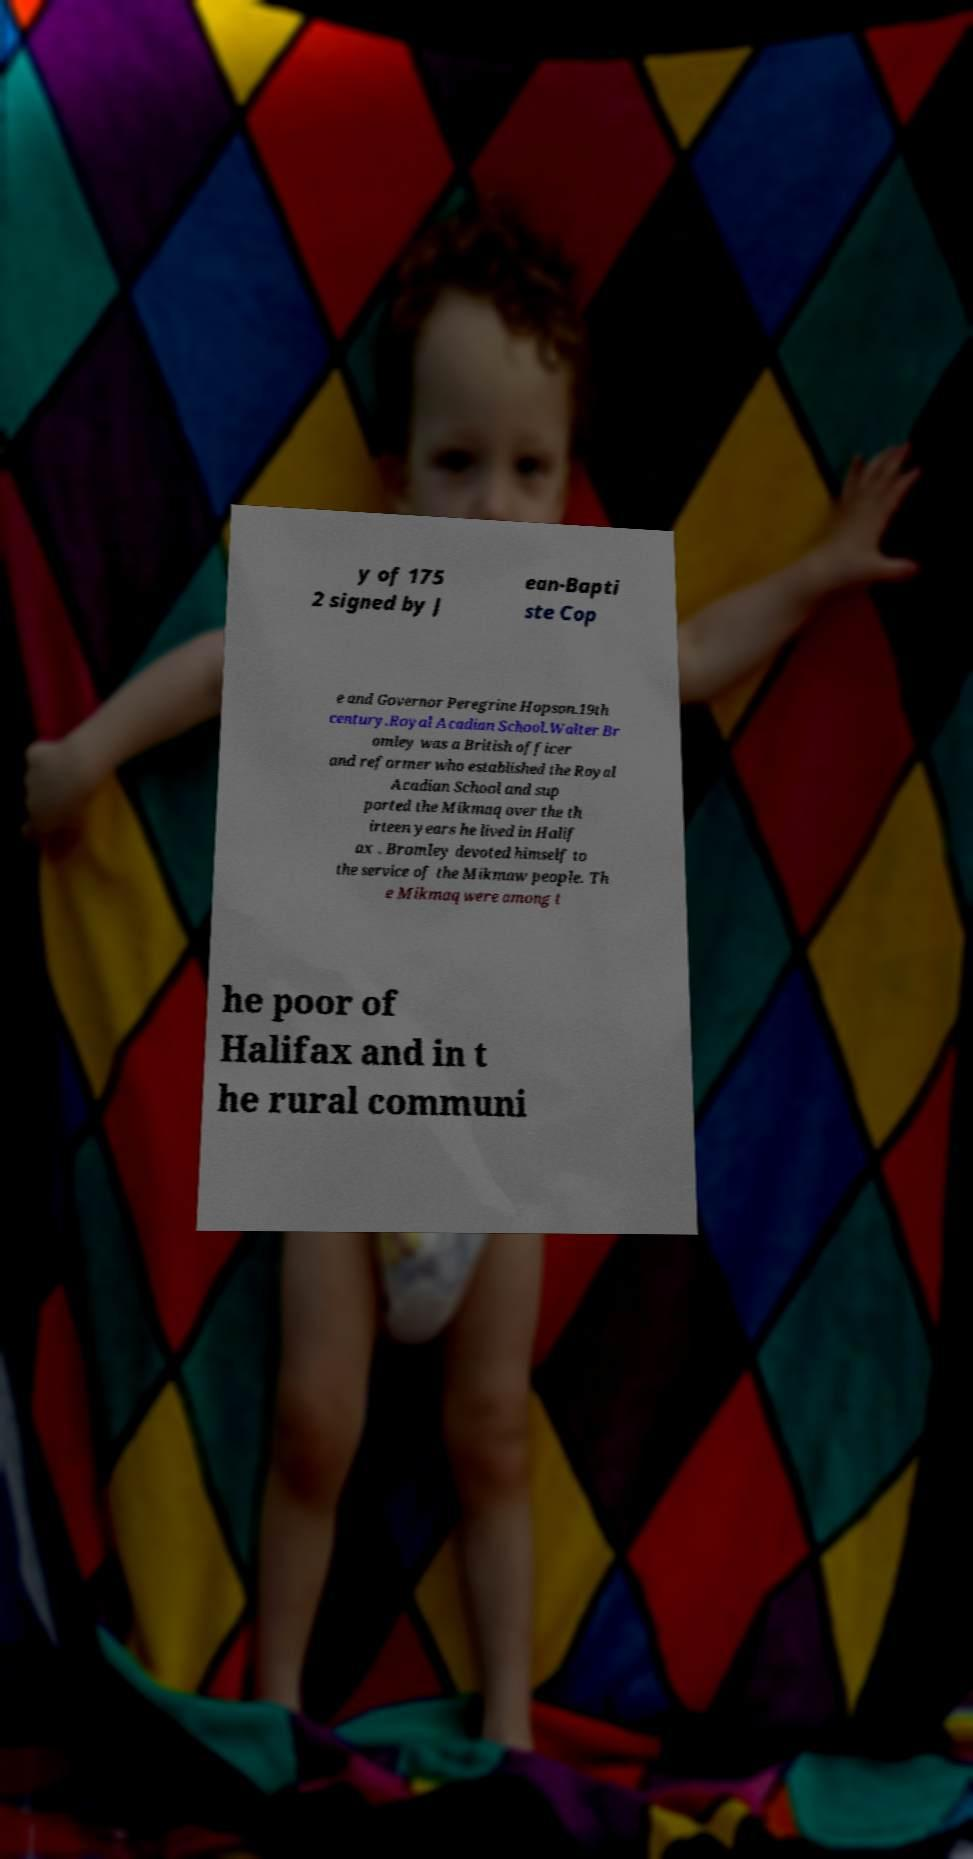For documentation purposes, I need the text within this image transcribed. Could you provide that? y of 175 2 signed by J ean-Bapti ste Cop e and Governor Peregrine Hopson.19th century.Royal Acadian School.Walter Br omley was a British officer and reformer who established the Royal Acadian School and sup ported the Mikmaq over the th irteen years he lived in Halif ax . Bromley devoted himself to the service of the Mikmaw people. Th e Mikmaq were among t he poor of Halifax and in t he rural communi 